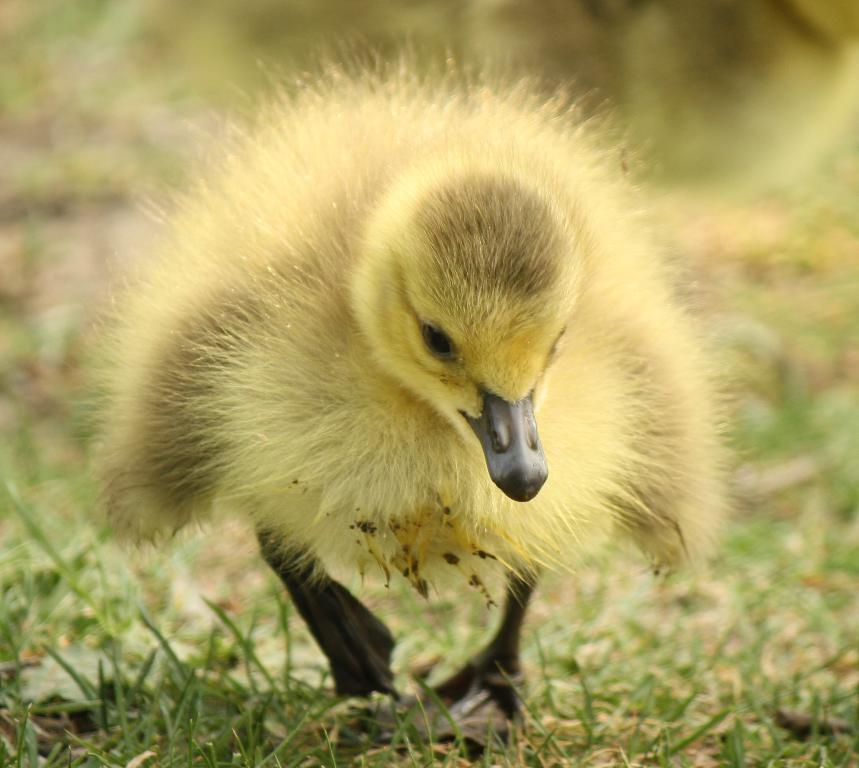What type of animal is in the image? The type of animal cannot be determined from the provided facts. Where is the animal located in the image? The animal is on the ground in the image. What can be seen in the background of the image? There is grass visible in the background of the image. How would you describe the background of the image? The background is blurry in the image. What type of oatmeal is being cooked in the kettle in the image? There is no kettle or oatmeal present in the image. How tall are the giants in the image? There are no giants present in the image. 